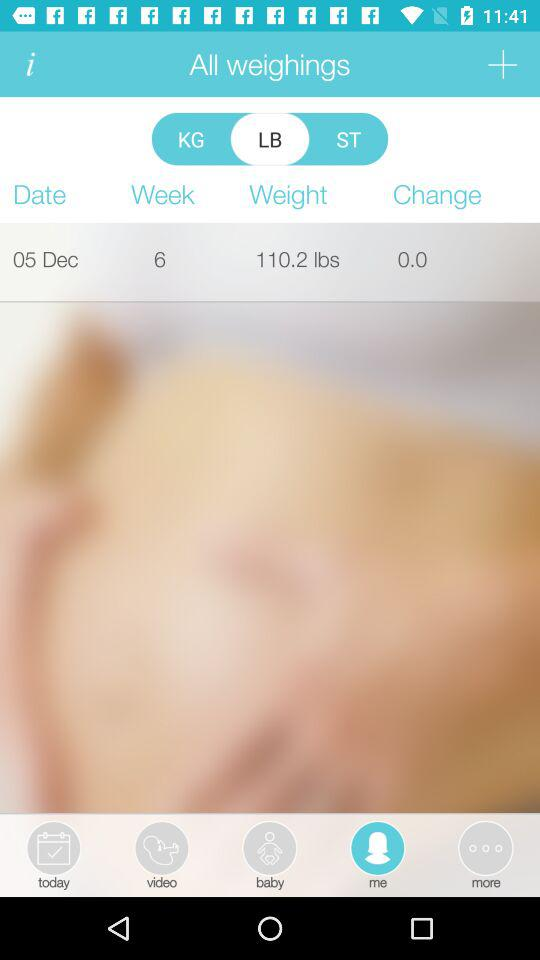What is the change in weight? The change in weight is 0. 